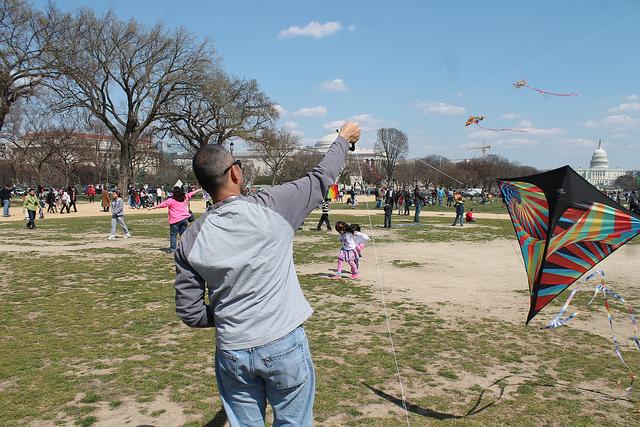How many kites are here?
Concise answer only. 3. How many of the man's arms are in the air?
Concise answer only. 1. Is the man facing the camera?
Answer briefly. No. What color is the man jeans?
Concise answer only. Blue. Is the man in the front longer than the kite he is flying?
Concise answer only. Yes. How many humans are in the foreground of the picture?
Concise answer only. 1. Where are they playing?
Quick response, please. Kites. 